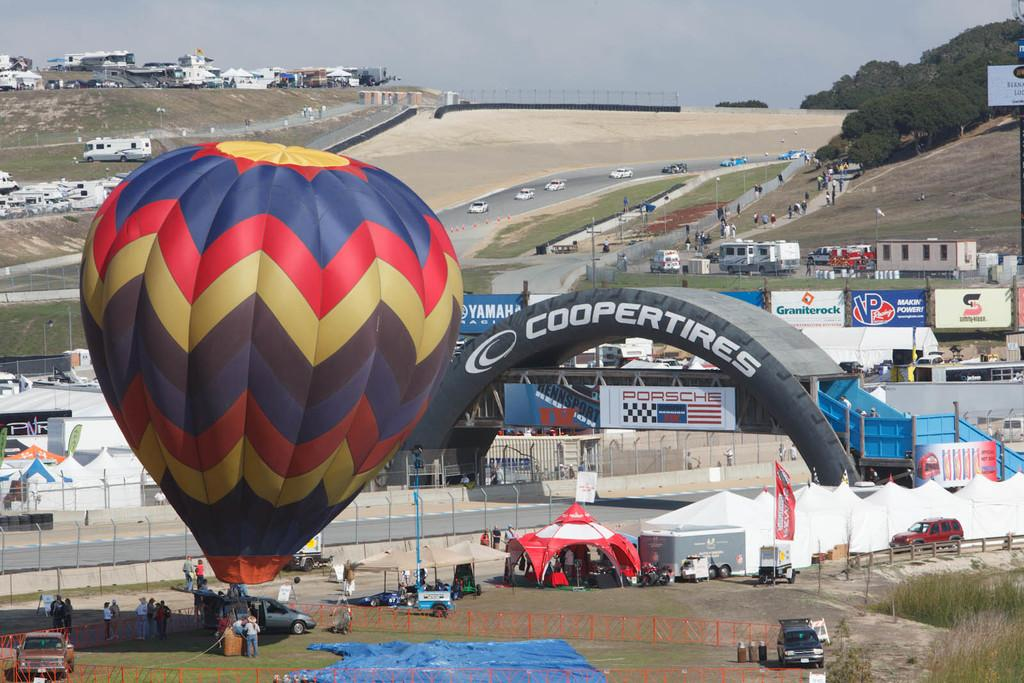Provide a one-sentence caption for the provided image. The racing event is sponsored by Cooper Tires and Porsche. 